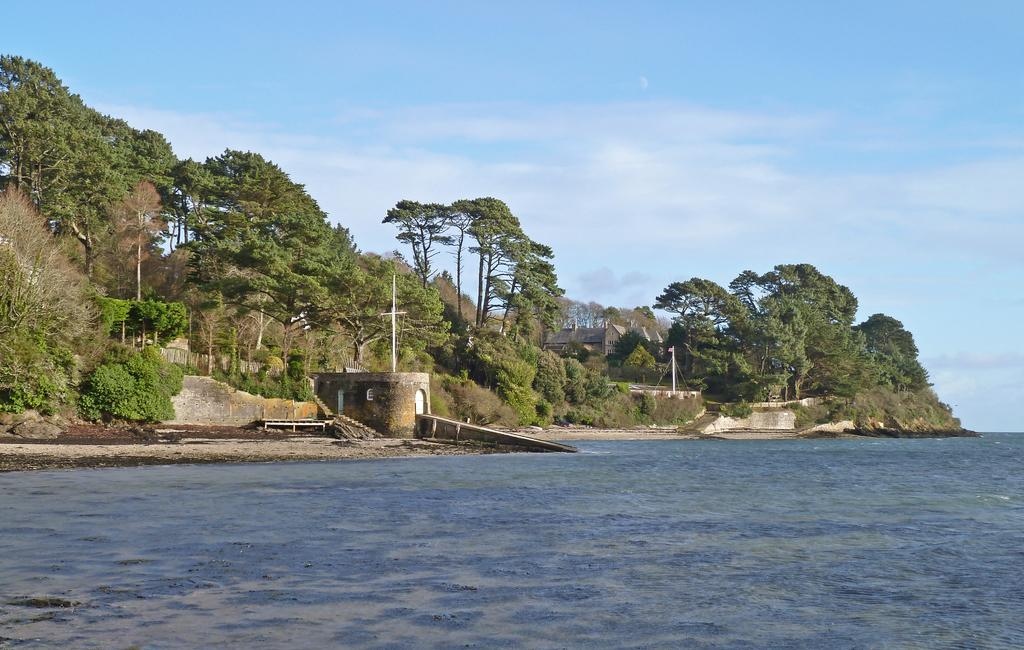What is the primary element visible in the image? There is water in the image. What can be seen in the background of the image? There is a wall, trees, a building, poles, plants, and clouds in the blue sky in the background of the image. What type of leather is being used to make the dog's interest in the image? There is no leather or dog present in the image, and therefore no such activity can be observed. 